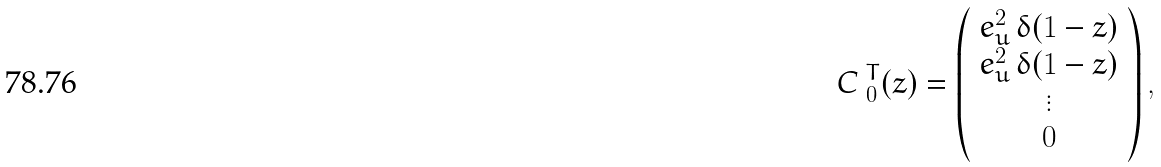<formula> <loc_0><loc_0><loc_500><loc_500>\emph { C } _ { 0 } ^ { T } ( z ) = \left ( \begin{array} { c } e _ { u } ^ { 2 } \, \delta ( 1 - z ) \\ e _ { u } ^ { 2 } \, \delta ( 1 - z ) \\ \vdots \\ 0 \\ \end{array} \right ) ,</formula> 